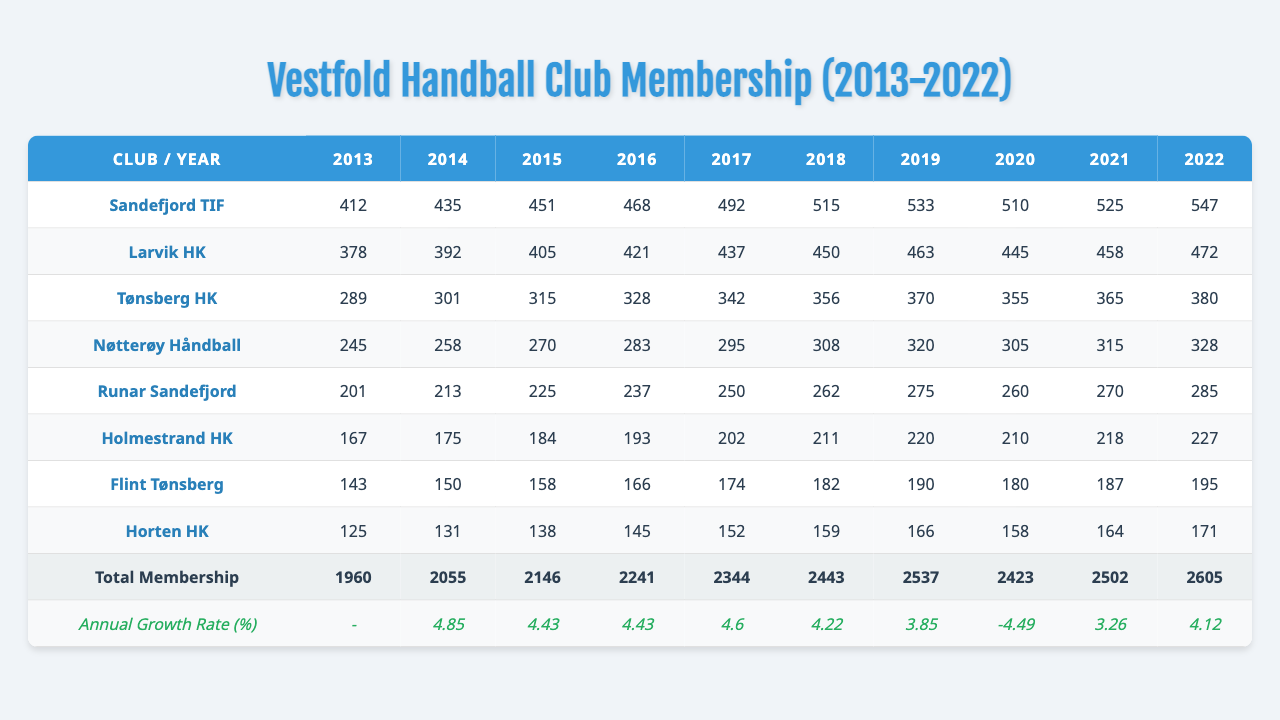What was the total membership for Sandefjord TIF in 2022? The table shows that Sandefjord TIF had a total membership of 547 in the year 2022.
Answer: 547 Which club had the highest total membership in 2019? According to the table, Sandefjord TIF had the highest total membership in 2019 with 533 members, compared to the other clubs listed.
Answer: Sandefjord TIF What is the average membership of Larvik HK over the past decade? The total membership of Larvik HK from 2013 to 2022 is 378 + 392 + 405 + 421 + 437 + 450 + 463 + 445 + 458 + 472 = 4226. Dividing by 10 gives an average of 422.6.
Answer: 422.6 Did Tønsberg HK experience growth in membership every year? Examining the membership for each year, Tønsberg HK had membership numbers that declined from 370 in 2019 to 355 in 2020, indicating a decrease that year, which shows that not every year experienced growth.
Answer: No What was the percentage growth of Runar Sandefjord from 2018 to 2019? For Runar Sandefjord, the membership in 2018 was 262 and in 2019 it was 275. The percent growth is calculated as ((275 - 262) / 262) * 100, which equals approximately 4.95%.
Answer: 4.95% Which club had the lowest membership in 2013? The table indicates that Flint Tønsberg had the lowest membership in 2013, with a count of 143 members.
Answer: Flint Tønsberg How much did the total membership increase from 2013 to 2022? The total membership in 2013 was 1960 and in 2022 it was 2605. The increase is calculated as 2605 - 1960 = 645 members.
Answer: 645 Which year saw the greatest annual growth rate for total membership? By analyzing the "Annual Growth Rate (%)" column, the highest growth rate is 4.85% which occurred in 2014.
Answer: 2014 What was the membership trend for Nøtterøy Håndball over the decade? The membership for Nøtterøy Håndball increased steadily from 245 in 2013 to 328 in 2022, indicating a consistent growth trend over the decade without any declines.
Answer: Steady growth Did any club have a decline in the total membership during the decade? Analyzing the membership numbers, Runar Sandefjord declined from 275 in 2019 to 260 in 2020, thus confirming that there was a decline for this club during that year.
Answer: Yes What is the difference in total membership between the highest and lowest clubs in 2022? In 2022, Sandefjord TIF had 547 members and Horten HK had 171 members. The difference is 547 - 171 = 376 members.
Answer: 376 